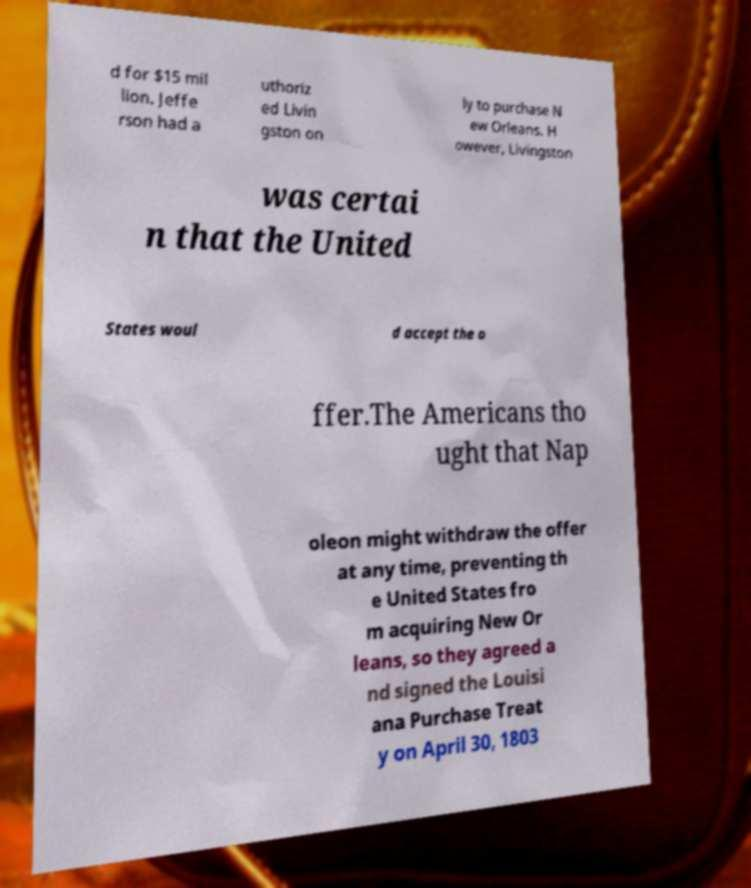I need the written content from this picture converted into text. Can you do that? d for $15 mil lion. Jeffe rson had a uthoriz ed Livin gston on ly to purchase N ew Orleans. H owever, Livingston was certai n that the United States woul d accept the o ffer.The Americans tho ught that Nap oleon might withdraw the offer at any time, preventing th e United States fro m acquiring New Or leans, so they agreed a nd signed the Louisi ana Purchase Treat y on April 30, 1803 